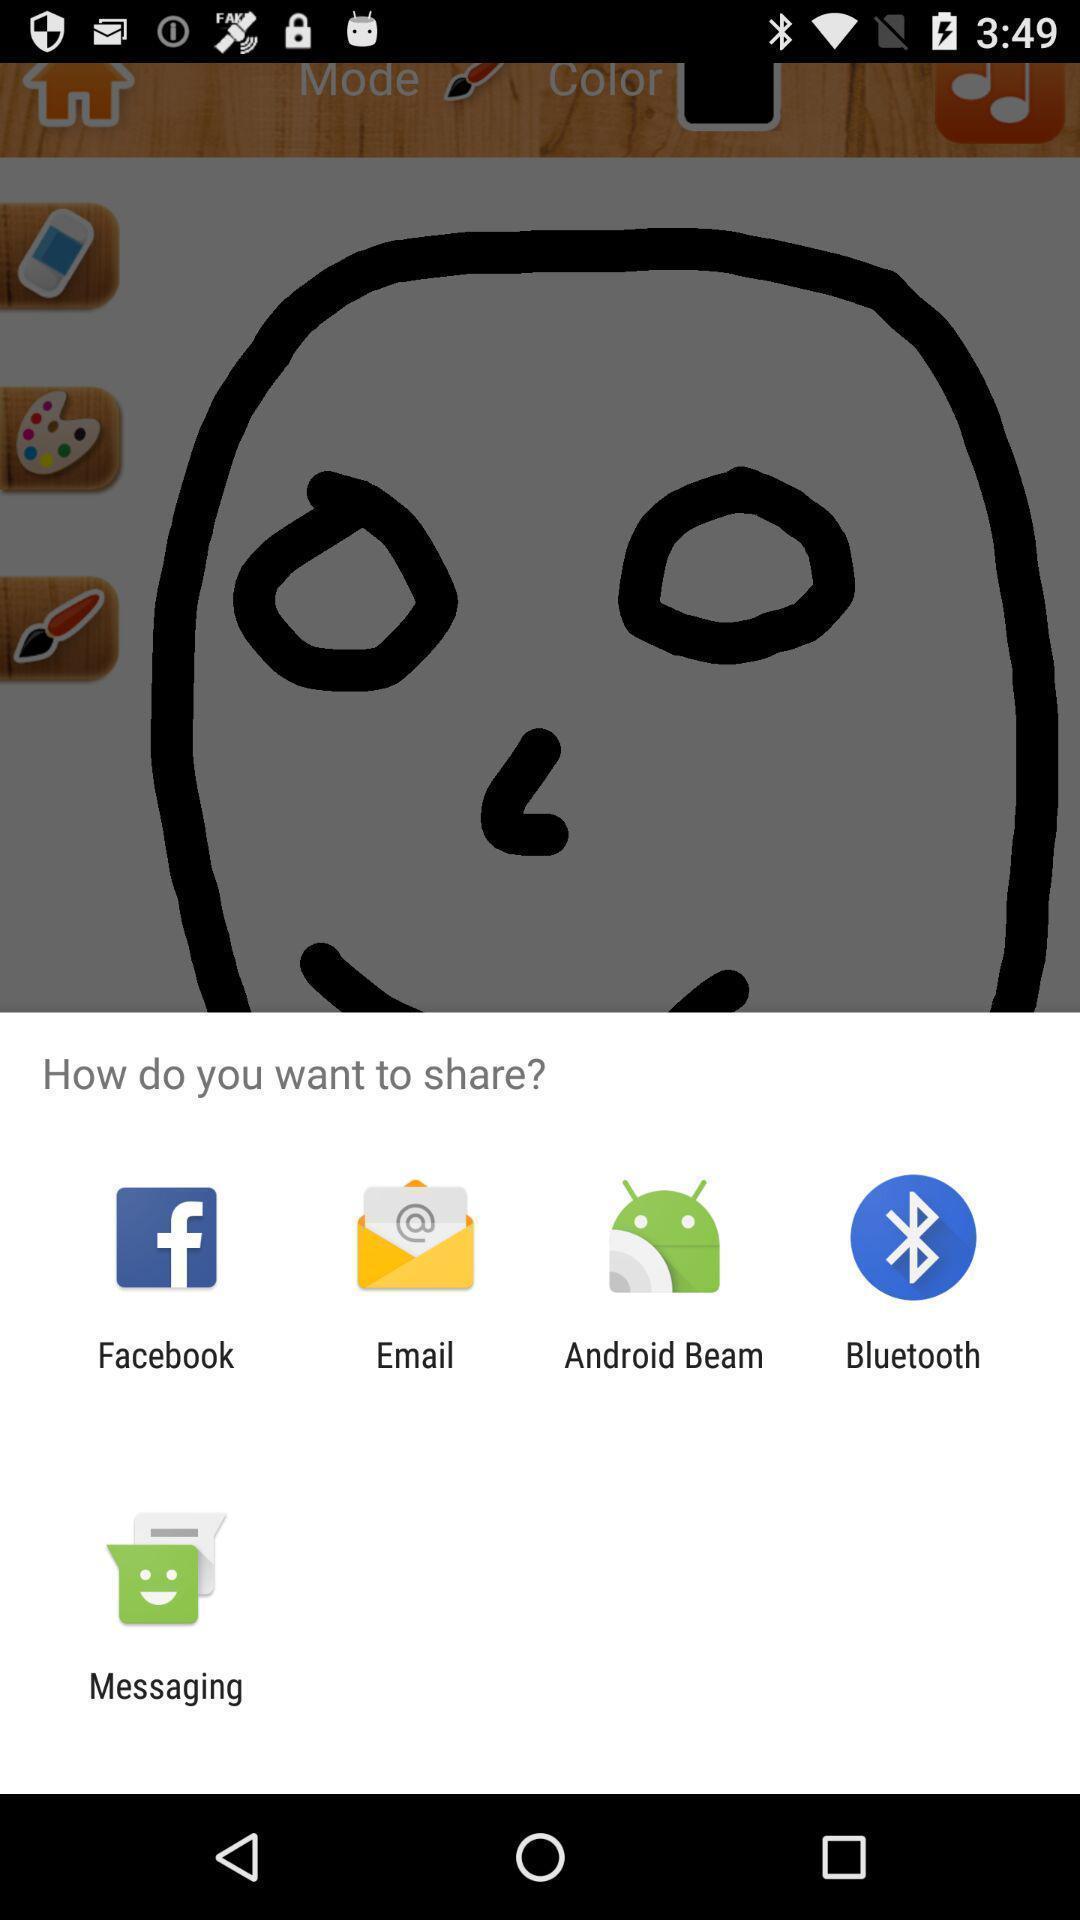Explain the elements present in this screenshot. Pop-up showing different applications to share. 